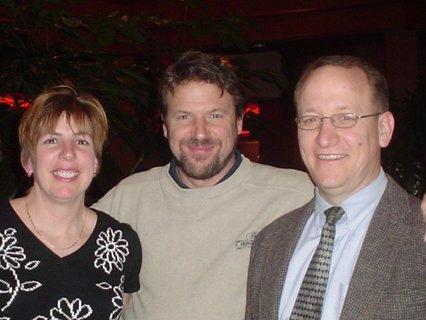The man in the middle has what feature?
Select the accurate answer and provide explanation: 'Answer: answer
Rationale: rationale.'
Options: Goatee, horns, third eye, triple chin. Answer: goatee.
Rationale: The facial hair is like a beard but does not cover the man's entire lower face. 